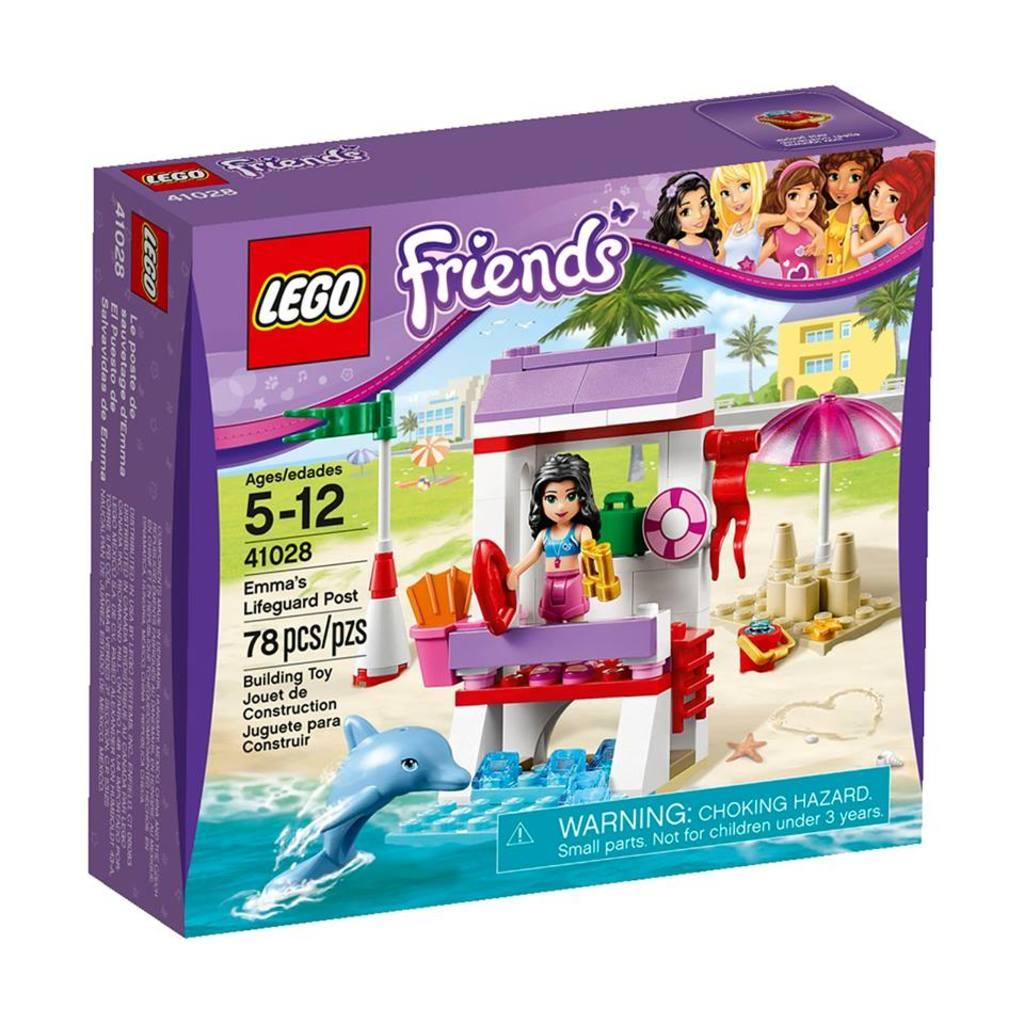What is the main object in the center of the image? There is a box in the center of the image. What can be found on the surface of the box? The box has some text on it, and there are animated images printed on it. Where are the animated images located on the box? The animated images are in the front of the box. How many men are smoking pipes in the image? There are no men or pipes present in the image; it features a box with text and animated images. 